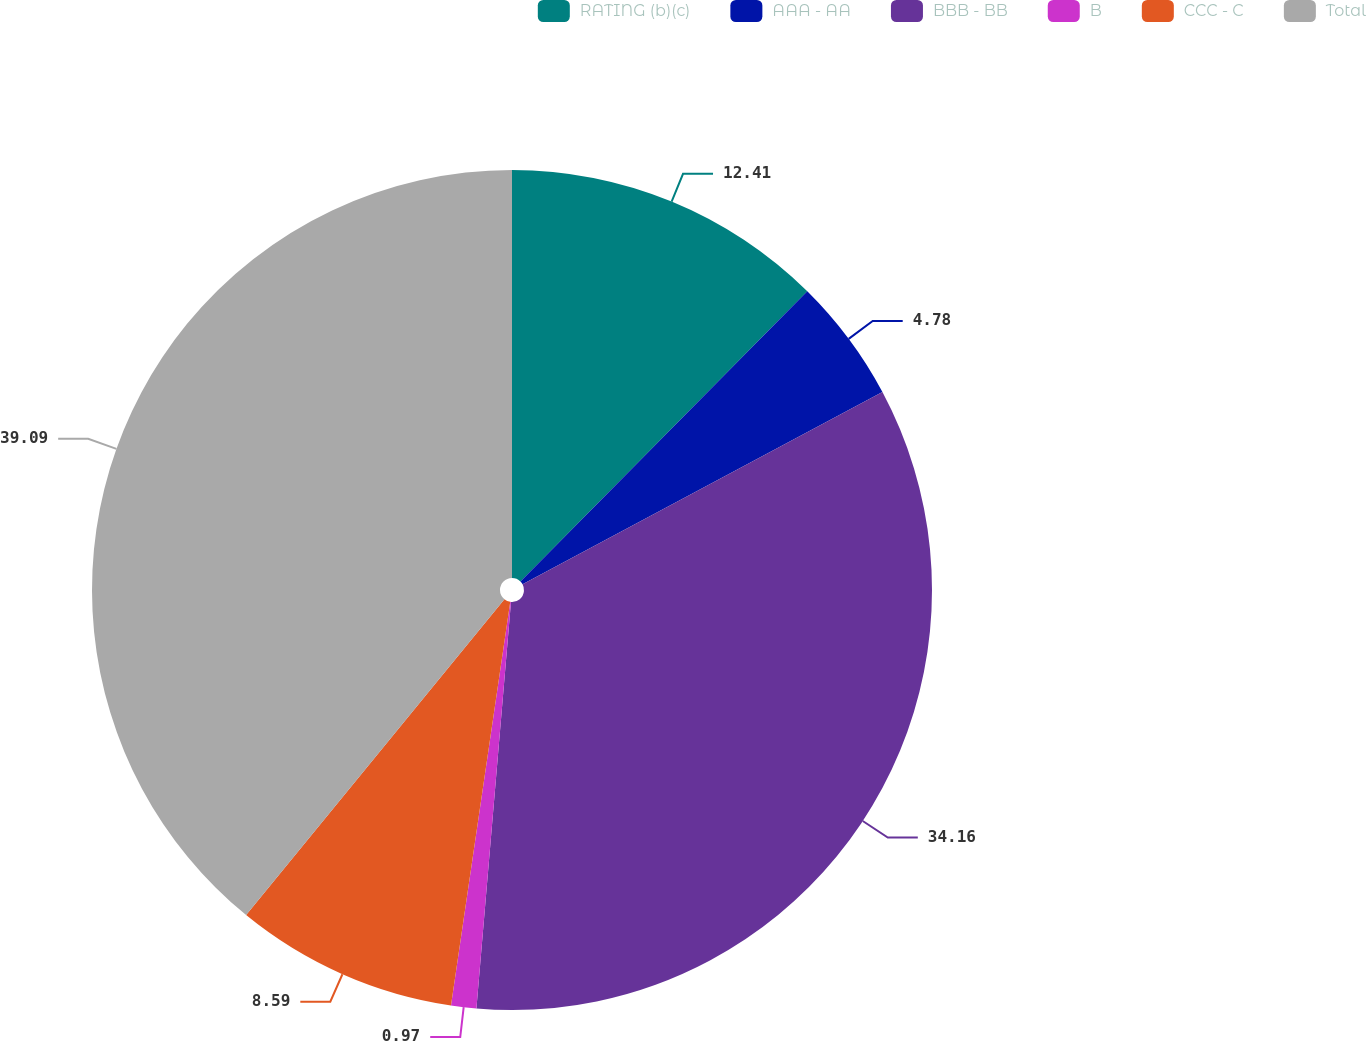Convert chart to OTSL. <chart><loc_0><loc_0><loc_500><loc_500><pie_chart><fcel>RATING (b)(c)<fcel>AAA - AA<fcel>BBB - BB<fcel>B<fcel>CCC - C<fcel>Total<nl><fcel>12.41%<fcel>4.78%<fcel>34.16%<fcel>0.97%<fcel>8.59%<fcel>39.09%<nl></chart> 